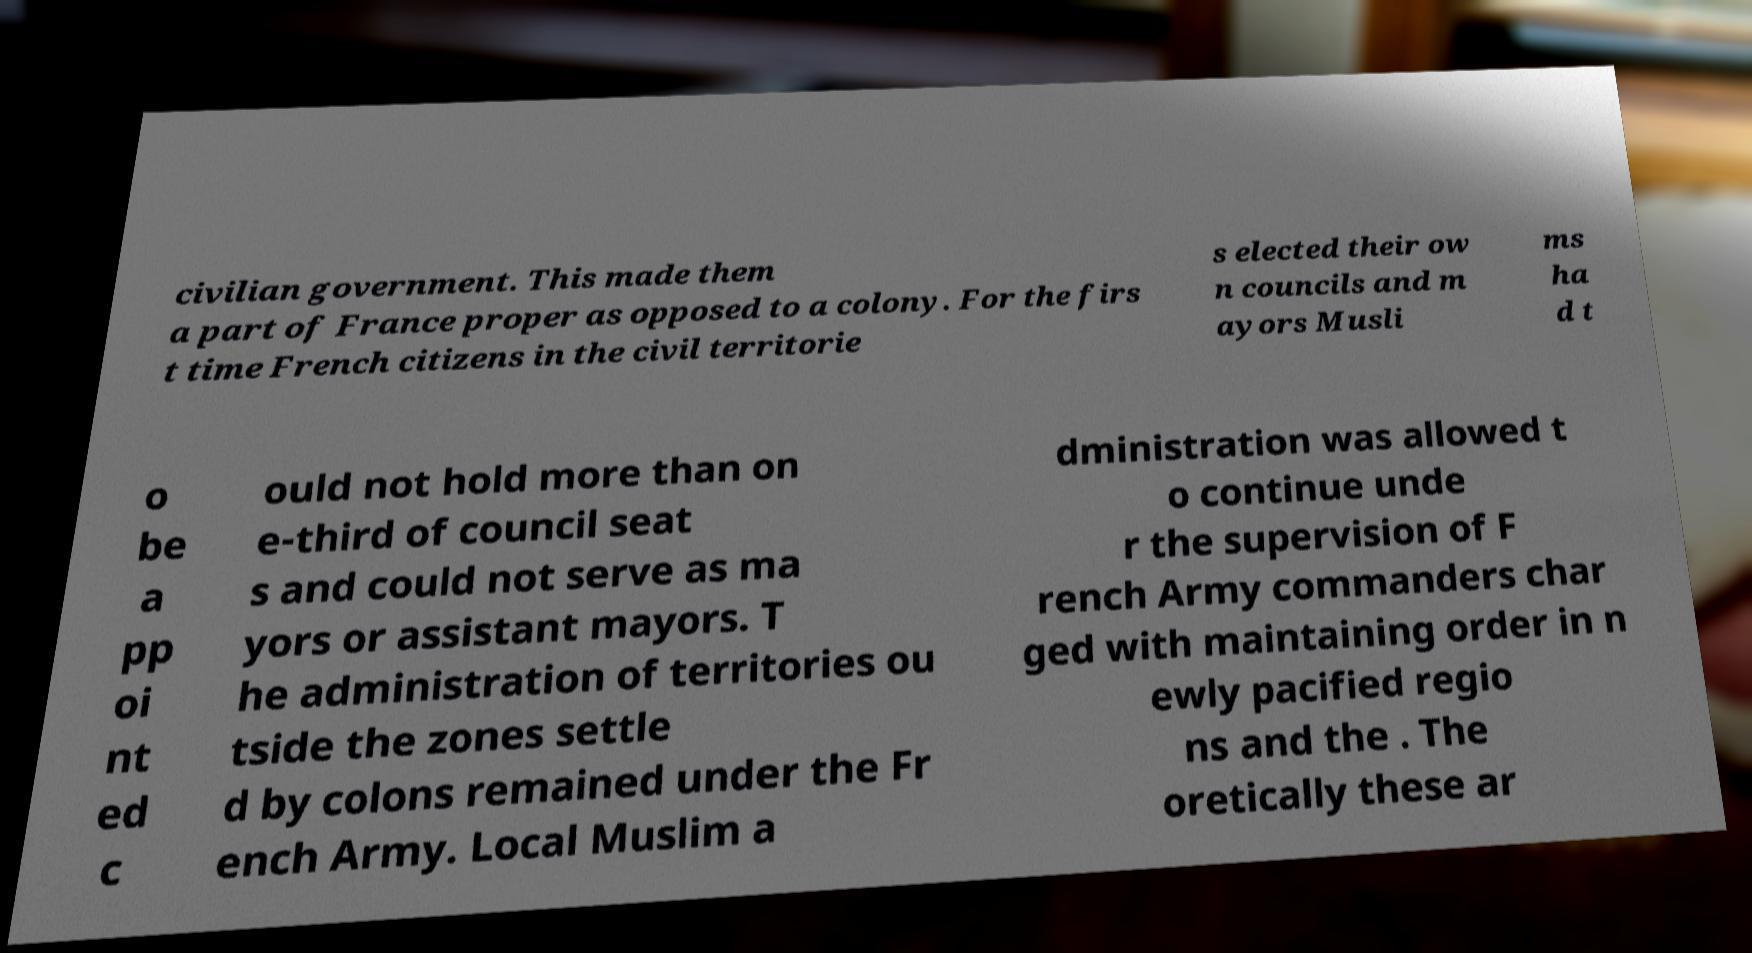Can you accurately transcribe the text from the provided image for me? civilian government. This made them a part of France proper as opposed to a colony. For the firs t time French citizens in the civil territorie s elected their ow n councils and m ayors Musli ms ha d t o be a pp oi nt ed c ould not hold more than on e-third of council seat s and could not serve as ma yors or assistant mayors. T he administration of territories ou tside the zones settle d by colons remained under the Fr ench Army. Local Muslim a dministration was allowed t o continue unde r the supervision of F rench Army commanders char ged with maintaining order in n ewly pacified regio ns and the . The oretically these ar 